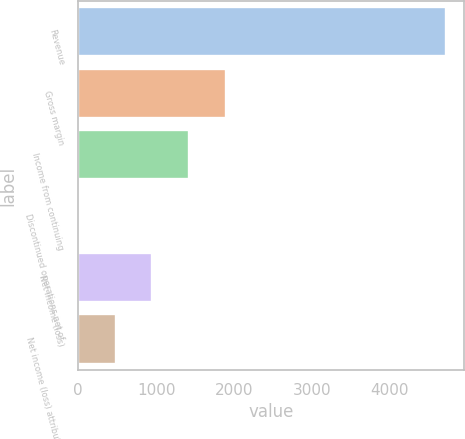<chart> <loc_0><loc_0><loc_500><loc_500><bar_chart><fcel>Revenue<fcel>Gross margin<fcel>Income from continuing<fcel>Discontinued operations net of<fcel>Net income (loss)<fcel>Net income (loss) attributable<nl><fcel>4722<fcel>1894.2<fcel>1422.9<fcel>9<fcel>951.6<fcel>480.3<nl></chart> 